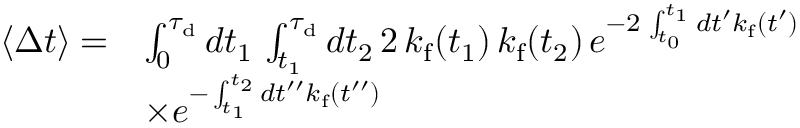Convert formula to latex. <formula><loc_0><loc_0><loc_500><loc_500>\begin{array} { r l } { \langle \Delta t \rangle = } & { \int _ { 0 } ^ { \tau _ { d } } d t _ { 1 } \, \int _ { t _ { 1 } } ^ { \tau _ { d } } d t _ { 2 } \, 2 \, k _ { f } ( t _ { 1 } ) \, k _ { f } ( t _ { 2 } ) \, e ^ { - 2 \, \int _ { t _ { 0 } } ^ { t _ { 1 } } d t ^ { \prime } k _ { f } ( t ^ { \prime } ) } } \\ & { \times e ^ { - \int _ { t _ { 1 } } ^ { t _ { 2 } } d t ^ { \prime \prime } k _ { f } ( t ^ { \prime \prime } ) } } \end{array}</formula> 